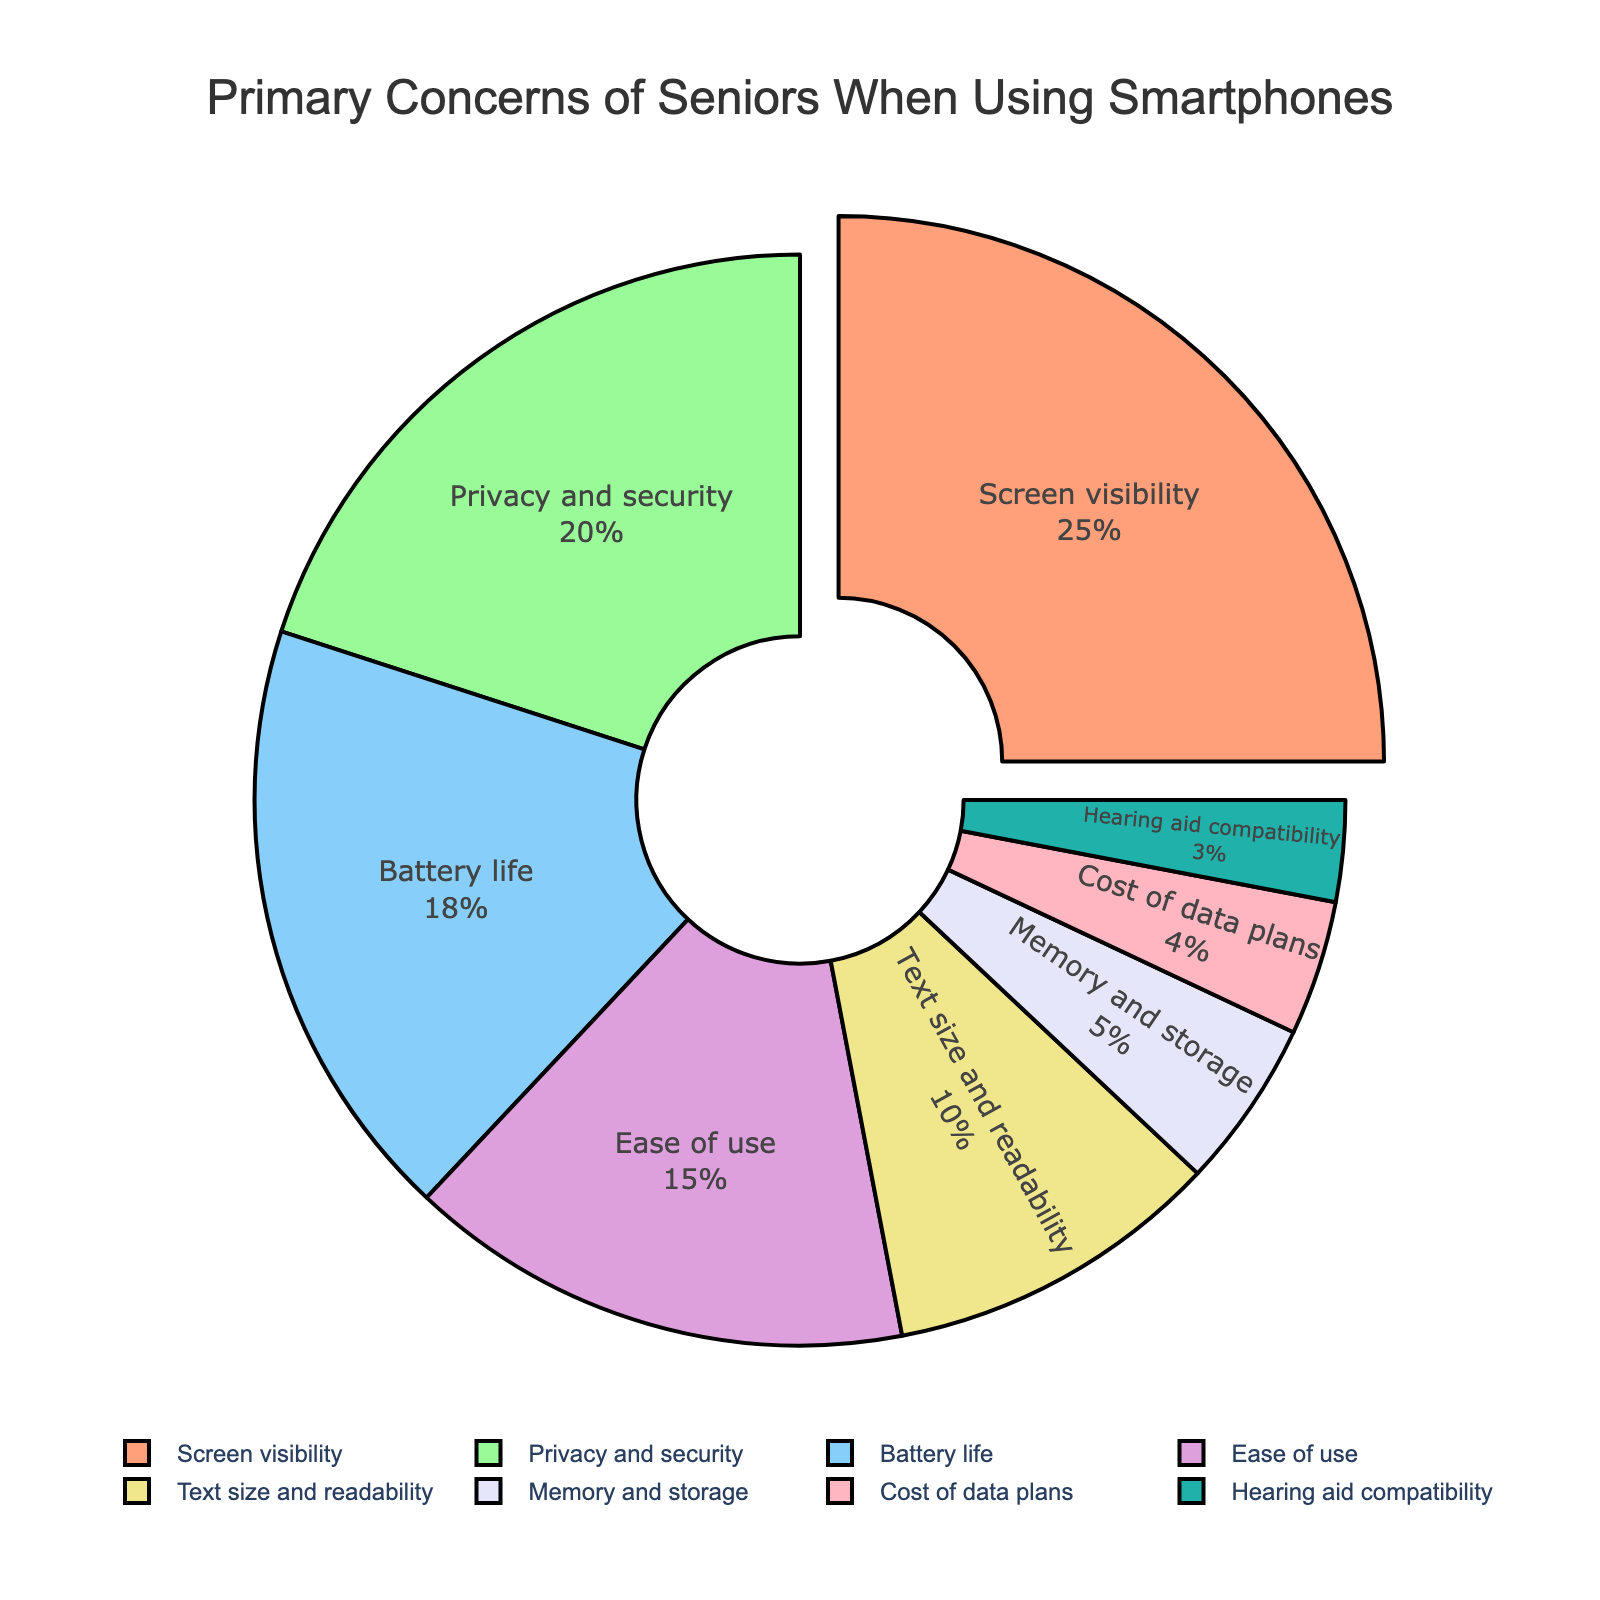Which concern is the most significant for seniors? By looking at the pie chart, the segment with the largest percentage represents the most significant concern. In this case, "Screen visibility" has the largest percentage at 25%.
Answer: Screen visibility How much larger is the percentage of "Screen visibility" compared to "Privacy and security"? To find the difference, subtract the percentage of "Privacy and security" from "Screen visibility". This is 25% - 20% = 5%.
Answer: 5% What is the combined percentage of concerns related to "Text size and readability" and "Hearing aid compatibility"? Add the percentages for "Text size and readability" and "Hearing aid compatibility". This is 10% + 3% = 13%.
Answer: 13% Which concerns occupy the smallest and largest segments of the pie chart respectively? By visually inspecting the pie chart, we can see that "Screen visibility" has the largest segment at 25%, while "Hearing aid compatibility" has the smallest segment at 3%.
Answer: Screen visibility, Hearing aid compatibility What is the total percentage of concerns related to battery and memory, specifically "Battery life" and "Memory and storage"? Add the percentages for "Battery life" and "Memory and storage". This is 18% + 5% = 23%.
Answer: 23% How does the size of the "Ease of use" segment compare to the "Battery life" segment? Compare the percentages of both segments, where "Ease of use" is 15% and "Battery life" is 18%. "Battery life" is 3% larger than "Ease of use".
Answer: Battery life is larger What is the percentage difference between the concern for "Cost of data plans" and "Privacy and security"? Subtract the percentage for "Cost of data plans" from "Privacy and security". This is 20% - 4% = 16%.
Answer: 16% If you combine the concerns for "Privacy and security", "Ease of use", and "Memory and storage", what is the total percentage? Add the percentages for "Privacy and security", "Ease of use", and "Memory and storage". This is 20% + 15% + 5% = 40%.
Answer: 40% Which concern is indicated by the green colored segment? Identify the segment colored in green and check its label. According to the provided colors, the green segment corresponds to "Privacy and security".
Answer: Privacy and security 